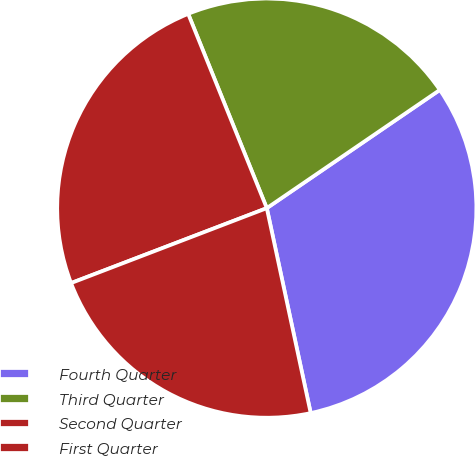Convert chart. <chart><loc_0><loc_0><loc_500><loc_500><pie_chart><fcel>Fourth Quarter<fcel>Third Quarter<fcel>Second Quarter<fcel>First Quarter<nl><fcel>31.18%<fcel>21.58%<fcel>24.7%<fcel>22.54%<nl></chart> 